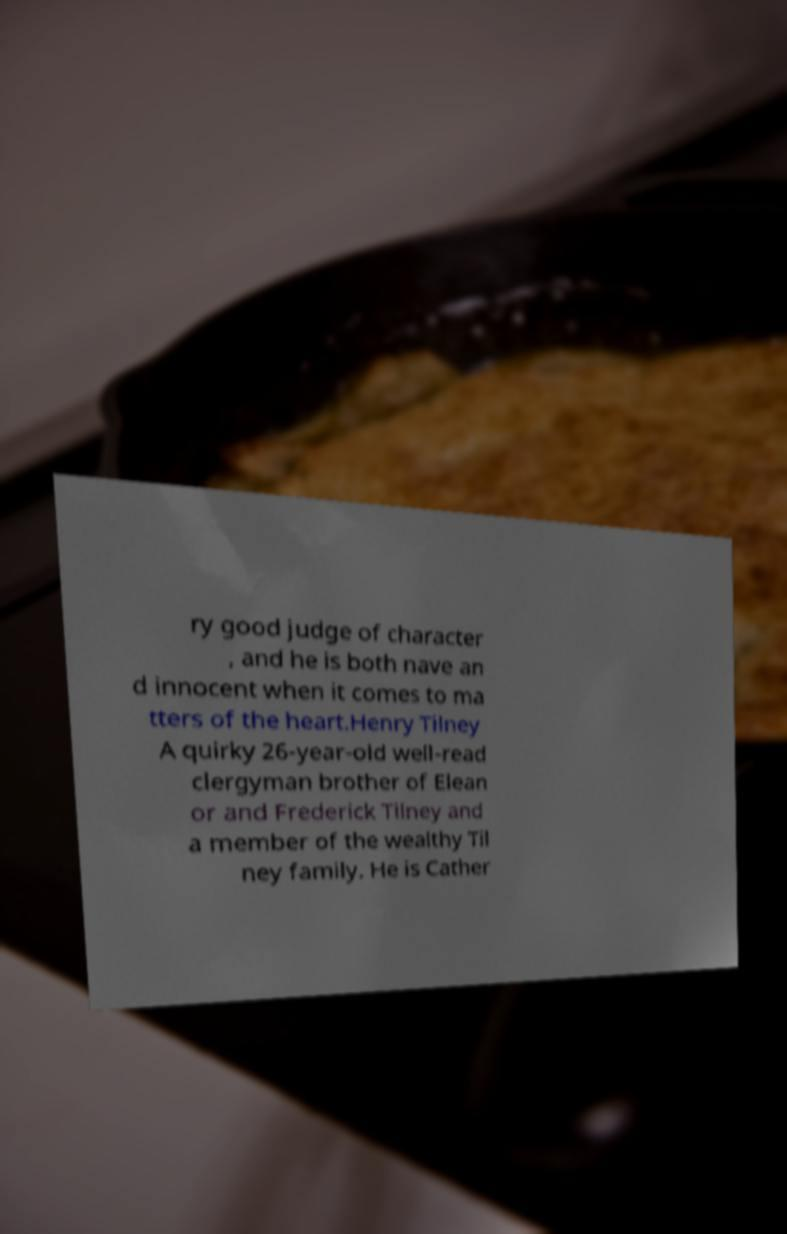Please read and relay the text visible in this image. What does it say? ry good judge of character , and he is both nave an d innocent when it comes to ma tters of the heart.Henry Tilney A quirky 26-year-old well-read clergyman brother of Elean or and Frederick Tilney and a member of the wealthy Til ney family. He is Cather 